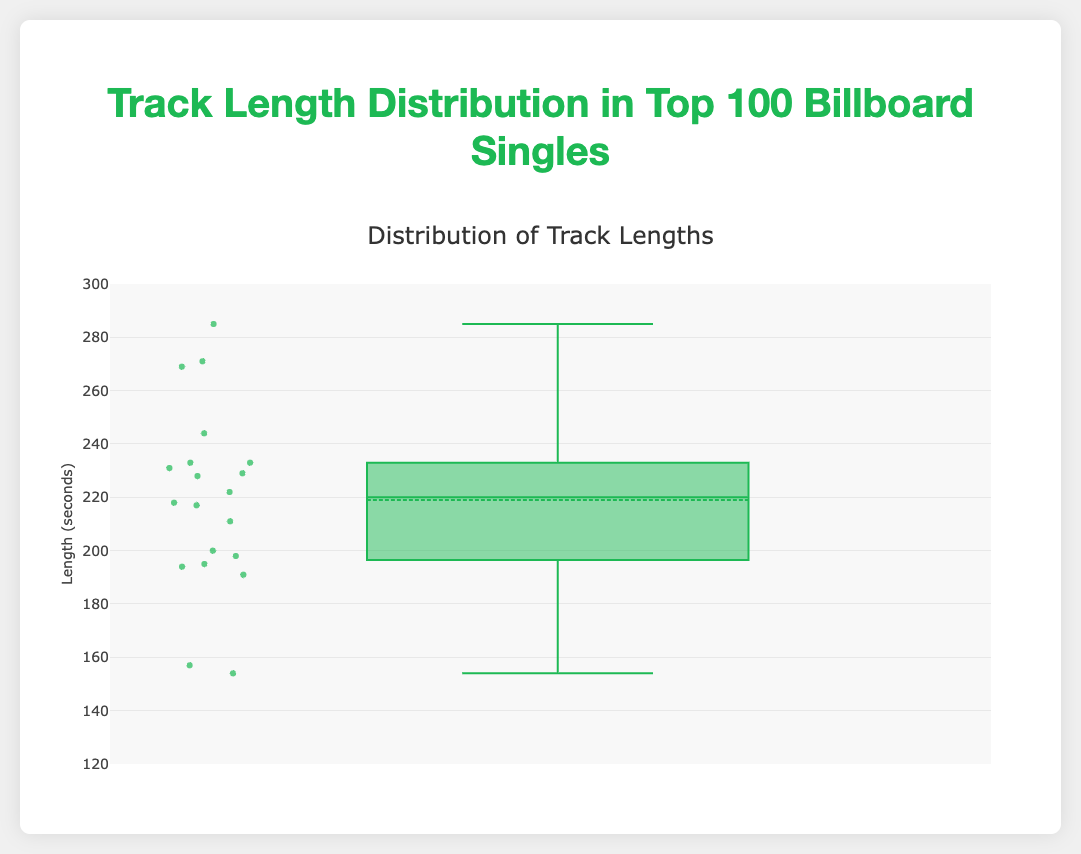What's the median length of the tracks? The median length is found by looking at the line within the box in the box plot.
Answer: 224 seconds What's the maximum length of the tracks? The highest point on the plot above the box whisker represents the maximum length.
Answer: 285 seconds What is the range of track lengths? The range is calculated by subtracting the minimum value from the maximum value. The plot shows a minimum around 154 and a maximum at 285. Therefore, the range is 285 - 154.
Answer: 131 seconds What's the interquartile range (IQR) of the track lengths? The IQR is the difference between the third quartile (Q3) and the first quartile (Q1). These can be identified by the top and bottom edges of the box. From the plot, Q3 is around 233 and Q1 is around 195. Therefore, the IQR is 233 - 195.
Answer: 38 seconds Which track has the shortest length? The shortest length corresponds to the lowest outlier below the box.
Answer: "Sunflower" by Post Malone & Swae Lee (154 seconds) What is the mean track length? The box plot includes a marker for the mean, represented by a dot inside the box.
Answer: Approximately 215 seconds Which track length is closest to the median? The median value is approximately 224 seconds. The track length closest to this is "God's Plan" by Drake (198 seconds).
Answer: "God's Plan" by Drake What proportion of tracks have a length longer than 240 seconds? First, count the total number of points. Then, identify the number of points greater than 240 seconds and divide by the total number. From the plot, four points are greater than 240 out of 20 total. The proportion is 4/20 or 20%.
Answer: 20% How does the length of "Blank Space" by Taylor Swift compare to the median track length? "Blank Space" has a duration of 231 seconds, while the median is around 224 seconds. Thus, "Blank Space" is slightly longer than the median track length.
Answer: Longer What could be the reason for the presence of outliers in the track length data? Outliers can occur due to tracks being significantly short or long compared to the general trend. In this dataset, "Sunflower" and "Old Town Road" are much shorter, while "Someone Like You" and "All of Me" are significantly longer.
Answer: Varied track lengths 